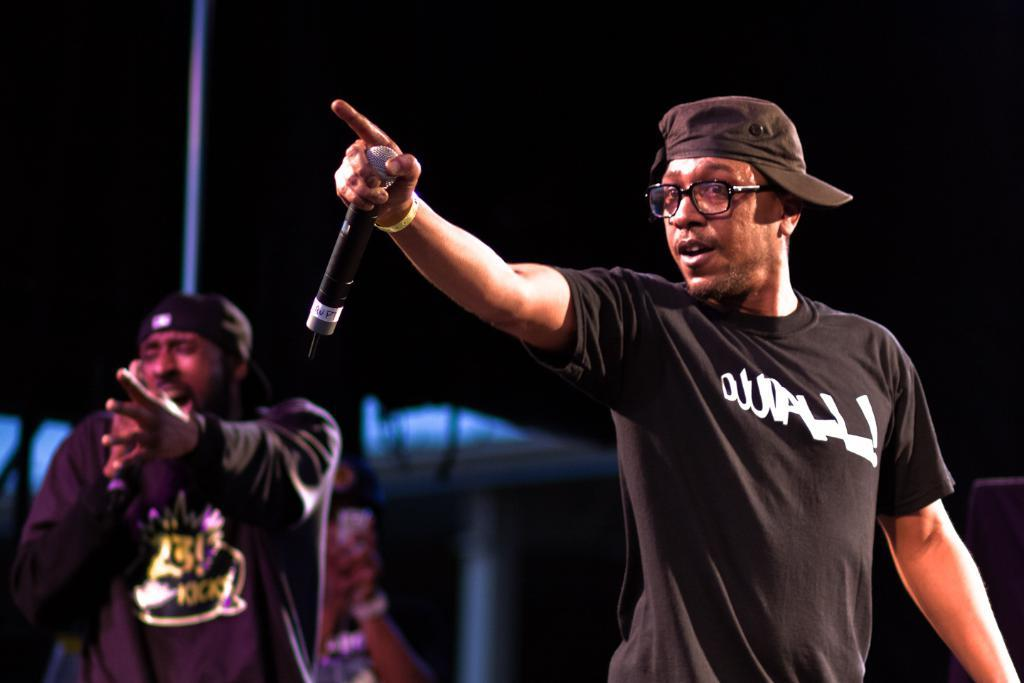How many people are in the image? There are two people in the image. What is one of the people holding? One of the people is holding a microphone. What is the other person doing in the image? The other person is singing. What is the income of the person holding the microphone in the image? There is no information about the income of the person holding the microphone in the image. 